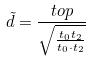<formula> <loc_0><loc_0><loc_500><loc_500>\tilde { d } = \frac { t o p } { \sqrt { \frac { t _ { 0 } t _ { 2 } } { t _ { 0 } \cdot t _ { 2 } } } }</formula> 